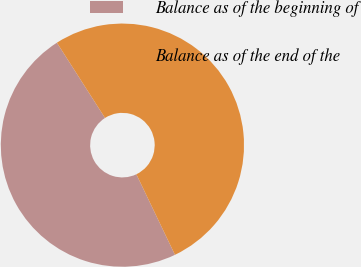<chart> <loc_0><loc_0><loc_500><loc_500><pie_chart><fcel>Balance as of the beginning of<fcel>Balance as of the end of the<nl><fcel>48.06%<fcel>51.94%<nl></chart> 